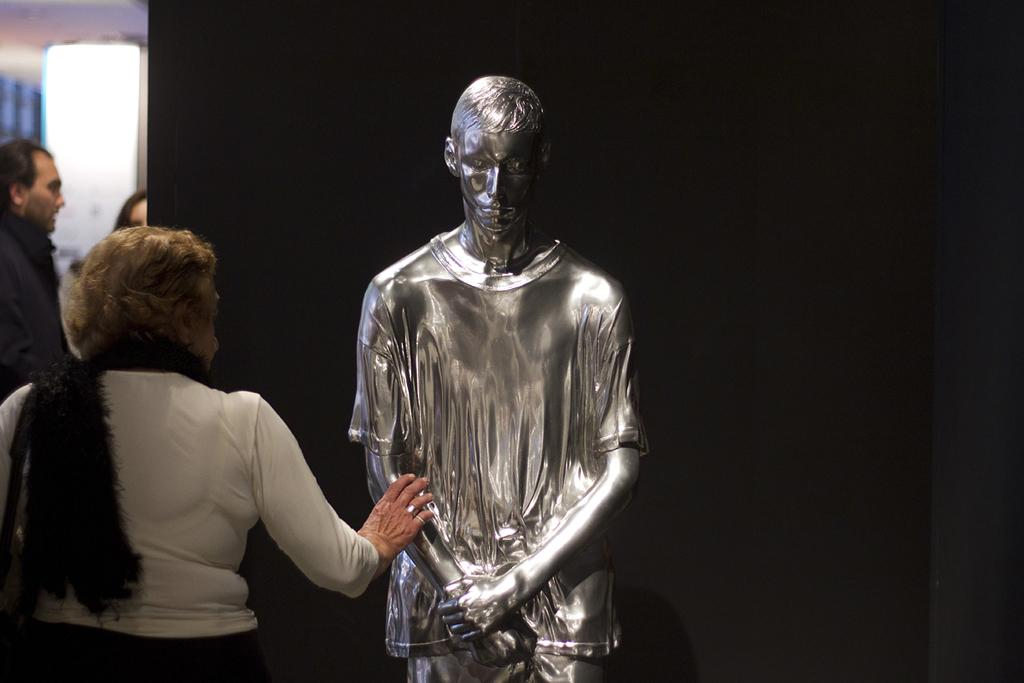What is the person on the left side of the image wearing? The person is wearing a white t-shirt and a stole. What can be seen in the middle of the image? There is a silver mannequin in the image. What color is the background of the image? The background of the image is black. Are there any other people visible in the image? Yes, there are other people visible in the left back of the image. What type of plantation can be seen in the image? There is no plantation present in the image; it features a person, a silver mannequin, and a black background. Is the person in the image sleeping? There is no indication in the image that the person is sleeping; they are wearing a white t-shirt and a stole and standing next to a silver mannequin. 